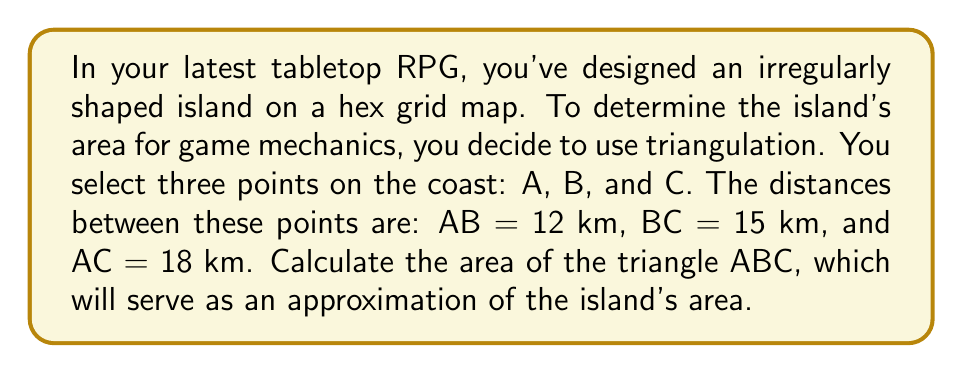Provide a solution to this math problem. To find the area of the triangle formed by points A, B, and C, we can use Heron's formula. This formula allows us to calculate the area of a triangle when we know the lengths of all three sides.

Let's follow these steps:

1) Heron's formula states that the area of a triangle with sides a, b, and c is:

   $$Area = \sqrt{s(s-a)(s-b)(s-c)}$$

   where s is the semi-perimeter of the triangle.

2) Calculate the semi-perimeter s:
   $$s = \frac{a + b + c}{2}$$
   $$s = \frac{12 + 15 + 18}{2} = \frac{45}{2} = 22.5\text{ km}$$

3) Now, let's substitute these values into Heron's formula:

   $$Area = \sqrt{22.5(22.5-12)(22.5-15)(22.5-18)}$$
   $$= \sqrt{22.5 \cdot 10.5 \cdot 7.5 \cdot 4.5}$$

4) Simplify under the square root:
   $$= \sqrt{7984.21875}$$

5) Calculate the square root:
   $$\approx 89.35\text{ km}^2$$

This area serves as an approximation of the island's size in your game world.

[asy]
unitsize(10mm);
pair A = (0,0), B = (12,0), C = (8,12);
draw(A--B--C--cycle);
label("A", A, SW);
label("B", B, SE);
label("C", C, N);
label("12 km", (A+B)/2, S);
label("15 km", (B+C)/2, NE);
label("18 km", (A+C)/2, NW);
[/asy]
Answer: The area of the triangle ABC, approximating the island's area, is approximately 89.35 km². 